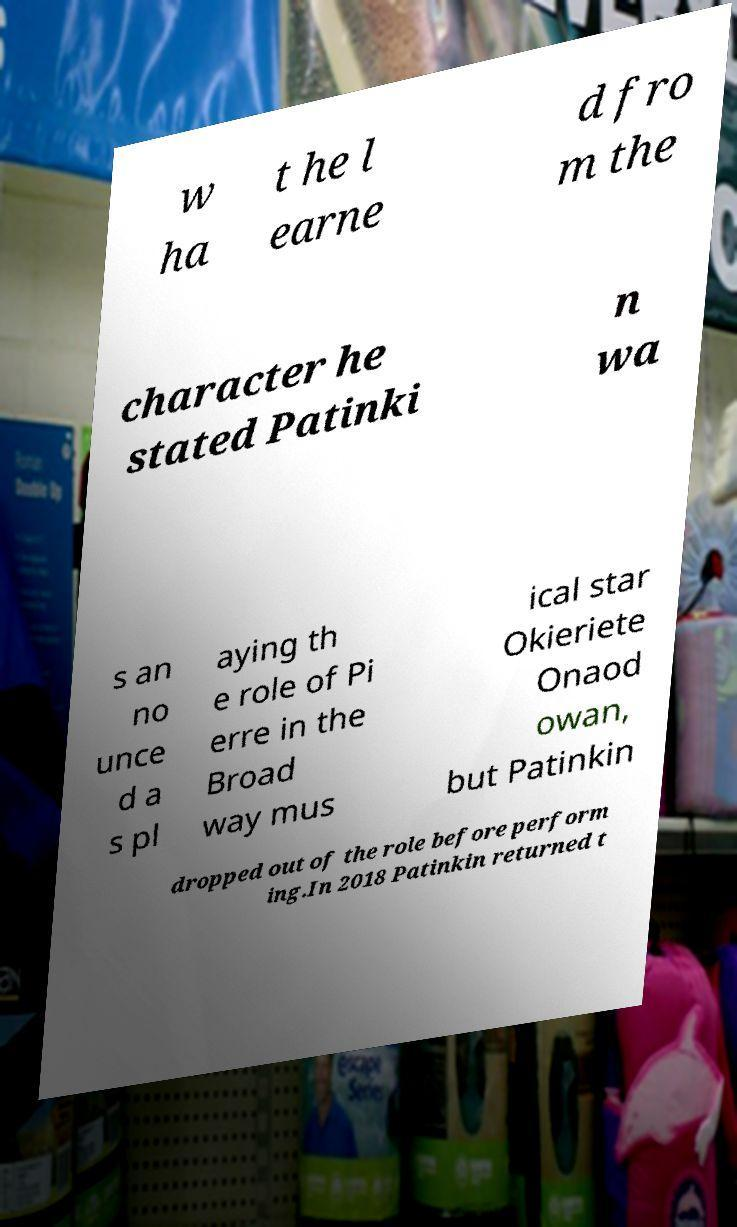What messages or text are displayed in this image? I need them in a readable, typed format. w ha t he l earne d fro m the character he stated Patinki n wa s an no unce d a s pl aying th e role of Pi erre in the Broad way mus ical star Okieriete Onaod owan, but Patinkin dropped out of the role before perform ing.In 2018 Patinkin returned t 